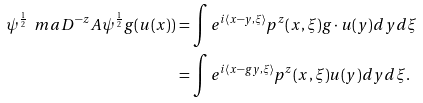Convert formula to latex. <formula><loc_0><loc_0><loc_500><loc_500>\psi ^ { \frac { 1 } { 2 } } \ m a D ^ { - z } A \psi ^ { \frac { 1 } { 2 } } g ( u ( x ) ) & = \int e ^ { i \langle x - y , \xi \rangle } p ^ { z } ( x , \xi ) g \cdot u ( y ) d y d \xi \\ & = \int e ^ { i \langle x - g y , \xi \rangle } p ^ { z } ( x , \xi ) u ( y ) d y d \xi .</formula> 